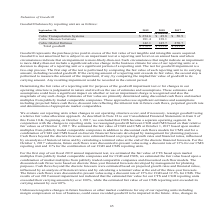According to Cubic's financial document, What does goodwill represent? the purchase price paid in excess of the fair value of net tangible and intangible assets acquired. The document states: "Goodwill represents the purchase price paid in excess of the fair value of net tangible and intangible assets acquired. Goodwill is not amortized but ..." Also, How are estimates of fair value primarily determined? using discounted cash flows and market multiples from publicly traded comparable companies. The document states: "Estimates of fair value are primarily determined using discounted cash flows and market multiples from publicly traded comparable companies. These app..." Also, Which reporting units are considered under the goodwill balances in the table? The document contains multiple relevant values: Cubic Transportation Systems, Cubic Mission Solutions, Cubic Global Defense. From the document: "ubic Transportation Systems $ 254.6 $ 49.8 $ 50.9 Cubic Mission Solutions 181.4 138.1 — Cubic Global Defense 142.1 145.7 270.7 Total goodwill $ 578.1 ..." Additionally, In which year was the goodwill balance for  Cubic Transportation Systems the lowest? According to the financial document, 2018. The relevant text states: "September 30, 2019 2018 2017 (in millions)..." Also, can you calculate: What is the change in the amount of total goodwill in 2019 from 2018? Based on the calculation: 578.1-333.6, the result is 244.5 (in millions). This is based on the information: "efense 142.1 145.7 270.7 Total goodwill $ 578.1 $ 333.6 $ 321.6 Global Defense 142.1 145.7 270.7 Total goodwill $ 578.1 $ 333.6 $ 321.6..." The key data points involved are: 333.6, 578.1. Also, can you calculate: What is the percentage change in the amount of total goodwill in 2019 from 2018? To answer this question, I need to perform calculations using the financial data. The calculation is: (578.1-333.6)/333.6, which equals 73.29 (percentage). This is based on the information: "efense 142.1 145.7 270.7 Total goodwill $ 578.1 $ 333.6 $ 321.6 Global Defense 142.1 145.7 270.7 Total goodwill $ 578.1 $ 333.6 $ 321.6..." The key data points involved are: 333.6, 578.1. 